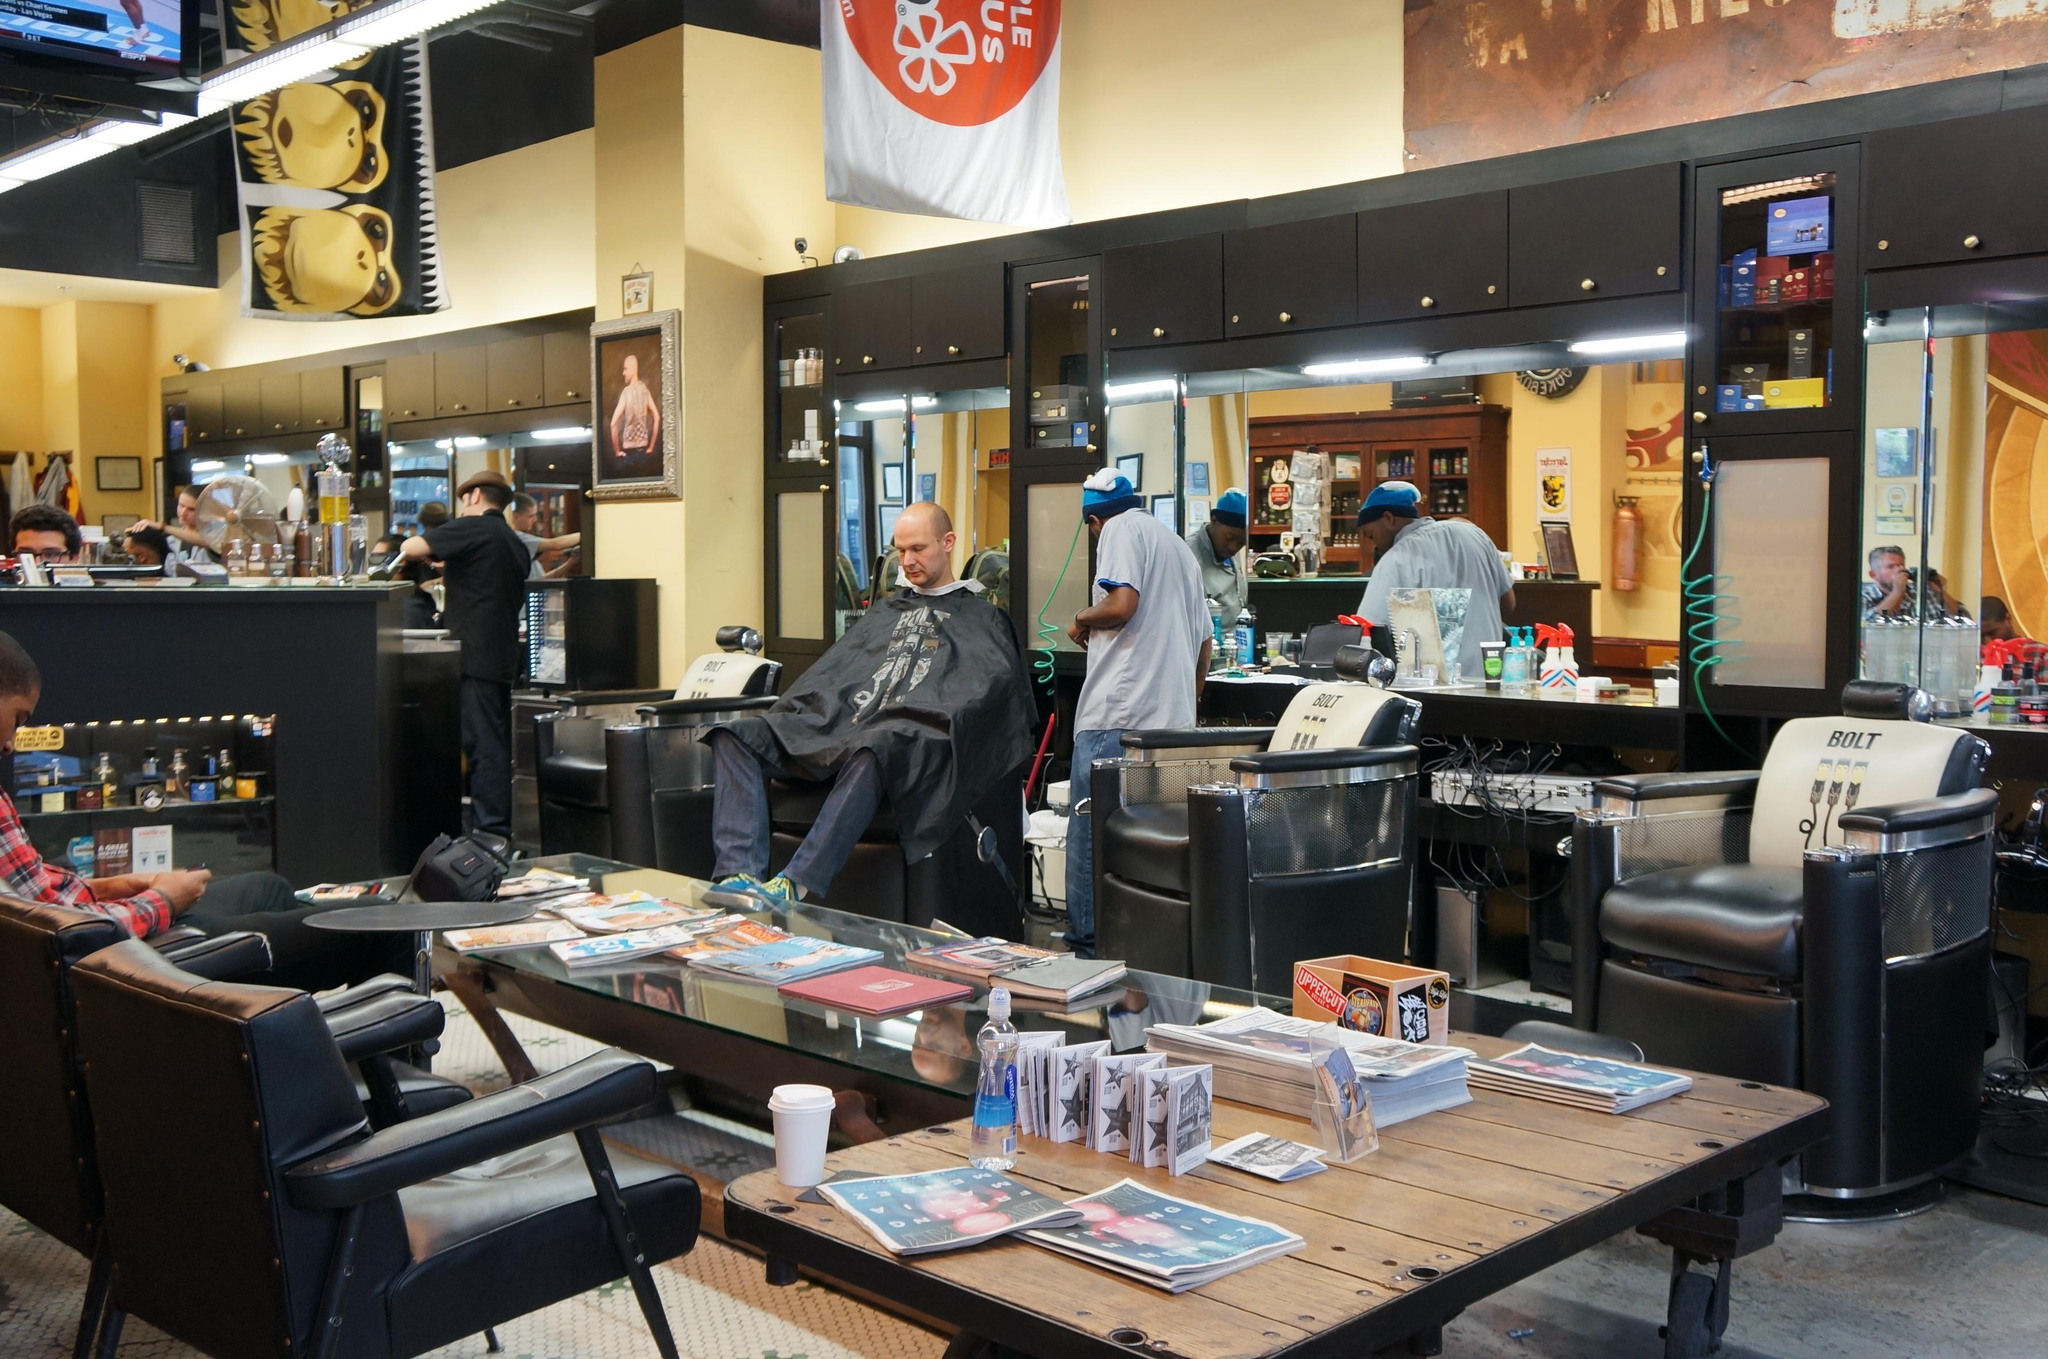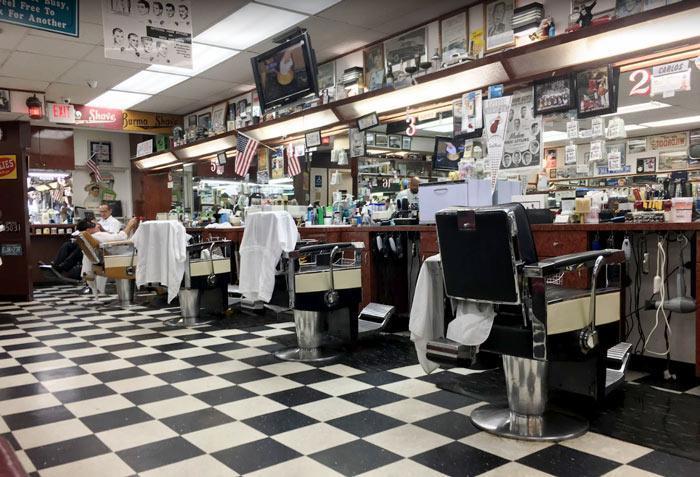The first image is the image on the left, the second image is the image on the right. Analyze the images presented: Is the assertion "The image on the right contains at least one person." valid? Answer yes or no. Yes. The first image is the image on the left, the second image is the image on the right. Analyze the images presented: Is the assertion "There is exactly one television screen in the image on the right." valid? Answer yes or no. Yes. 